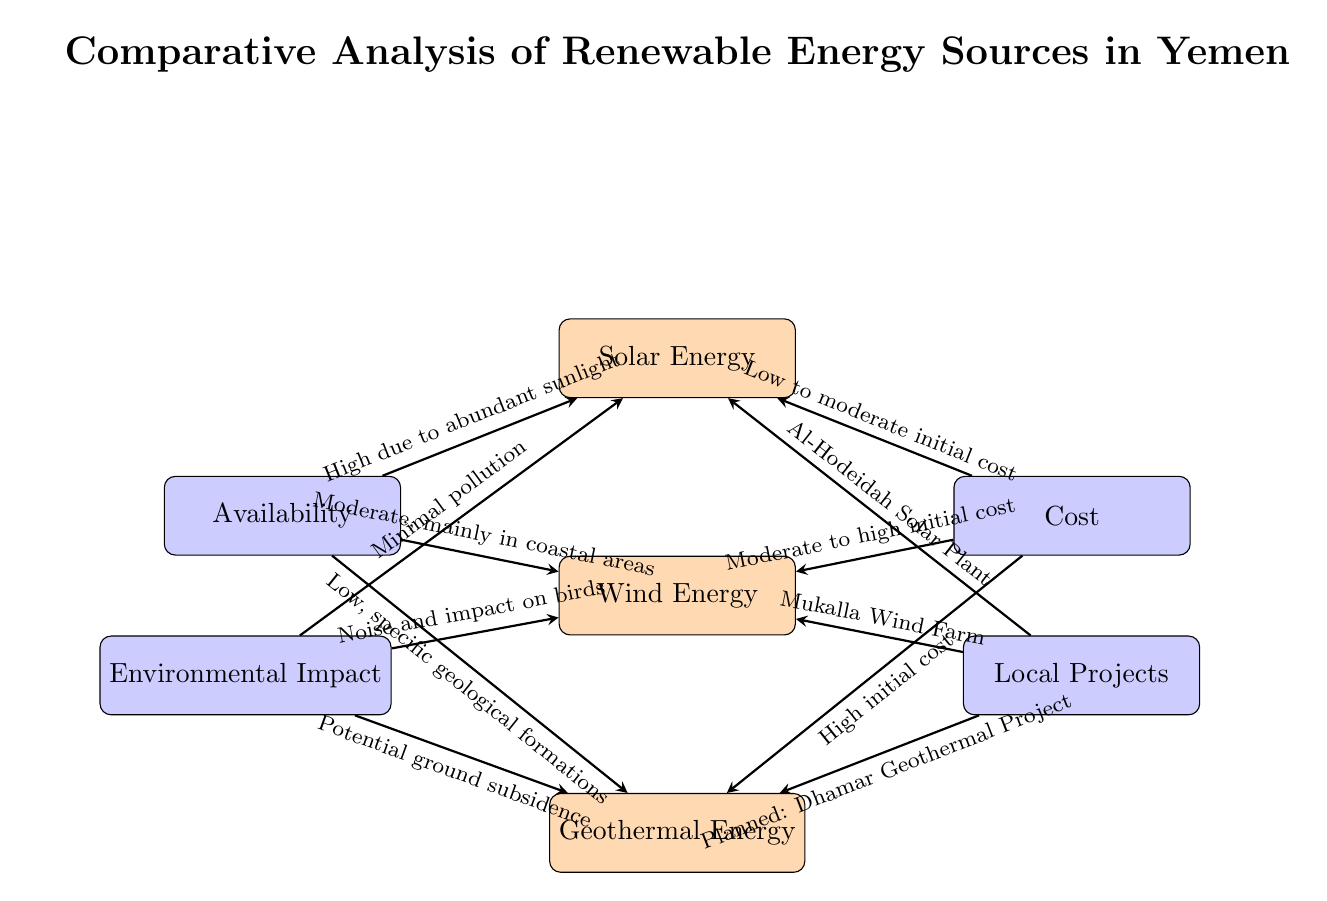What are the three types of renewable energy sources shown? The diagram shows three renewable energy sources: Solar Energy, Wind Energy, and Geothermal Energy. This information can be found in the labeled energy blocks at the top and middle of the diagram.
Answer: Solar Energy, Wind Energy, Geothermal Energy Which renewable energy source has the highest availability? The diagram indicates that Solar Energy has a high availability due to abundant sunlight, as stated in the arrow leading to this node.
Answer: Solar Energy What is the environmental impact of Wind Energy according to the diagram? The diagram specifies that the environmental impact of Wind Energy is characterized by noise and impact on birds, as indicated in the corresponding arrow description.
Answer: Noise and impact on birds Which renewable source has the lowest initial cost? The diagram shows that Solar Energy has a low to moderate initial cost, which is referenced in the arrow pointing towards the Solar Energy node.
Answer: Low to moderate What is the planned geothermal project mentioned in the diagram? The diagram refers to the "Dhamar Geothermal Project" as the planned project for geothermal energy, located in the arrow leading to the Geothermal Energy node.
Answer: Dhamar Geothermal Project Which source has the highest initial cost? According to the diagram, Geothermal Energy has a high initial cost, as stated in the arrow that connects the cost factor to the Geothermal Energy node.
Answer: High Which energy source represents local project involvement in Al-Hodeidah? The diagram clearly states that the local project in Al-Hodeidah pertains to Solar Energy, as highlighted in the arrow leading to this renewable source.
Answer: Al-Hodeidah Solar Plant How many factors are influencing the renewable energy sources in the diagram? There are four factors in the diagram: Availability, Cost, Environmental Impact, and Local Projects. This can be counted by observing the number of factor blocks.
Answer: Four 